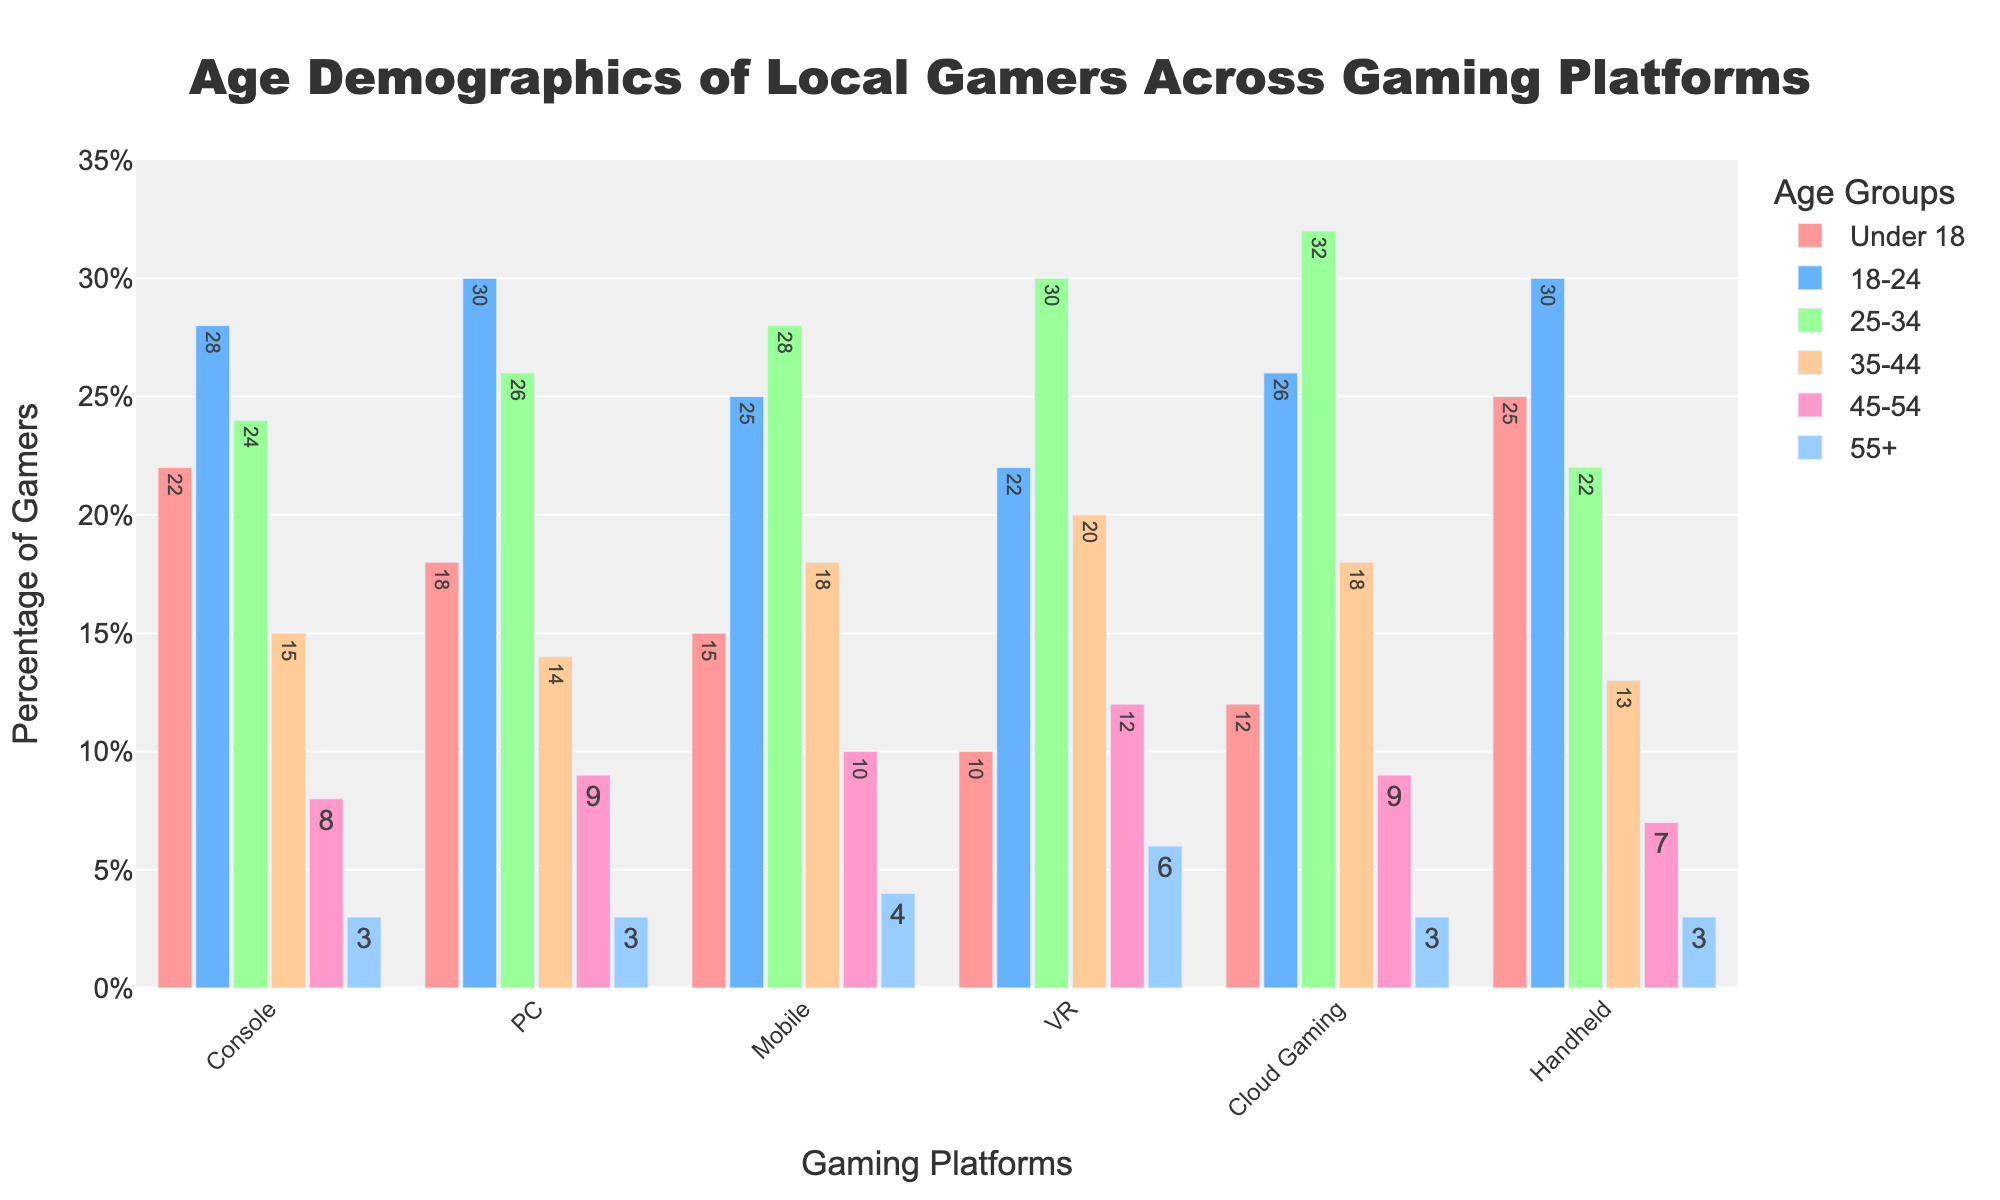Which platform shows the highest percentage of gamers aged 25-34? The VR platform shows the highest percentage of gamers aged 25-34 with a value of 30% as indicated by the height of the corresponding bar.
Answer: VR Which age group is most prevalent across all platforms? We need to compare the heights of the bars for each age group across all platforms. The age group 25-34 has consistently high percentages across most platforms with some of the highest individual values.
Answer: 25-34 Which platform has the lowest percentage of gamers aged under 18? By looking at the smallest bars in the 'Under 18' category, VR has the lowest percentage (10%) among all platforms.
Answer: VR On which platforms is the percentage of gamers aged 55+ equal? The bar heights for the '55+' category in Console, PC, Handheld, and Cloud Gaming are equal, all at 3%.
Answer: Console, PC, Handheld, Cloud Gaming What is the difference in the percentage of gamers aged 18-24 between Console and VR? The percentage for Console is 28%, and for VR, it is 22%. The difference is 28% - 22% = 6%.
Answer: 6% Which two platforms have the highest combined percentage of gamers aged 35-44? Looking at the values for the 35-44 category, the highest values are VR (20%) and Mobile (18%). Combined, they are 20% + 18% = 38%.
Answer: VR and Mobile How many platforms have more than 25% of gamers aged 25-34? By checking each platform's bar for the 25-34 category, PC (26%), Mobile (28%), VR (30%), and Cloud Gaming (32%) all exceed 25%. There are 4 such platforms.
Answer: 4 For which platform is the distribution of gamers across all age groups the most even? The VR platform has relatively balanced bar heights across all age groups, indicating a more even distribution.
Answer: VR Which age group has the smallest range of percentages across all platforms? The 55+ age group has the smallest range, varying between 3% and 6% across different platforms.
Answer: 55+ What's the total percentage of gamers aged 18-24 and 25-34 on the Cloud Gaming platform? The 18-24 age group has 26%, and the 25-34 age group has 32%. Combined, they are 26% + 32% = 58%.
Answer: 58% 